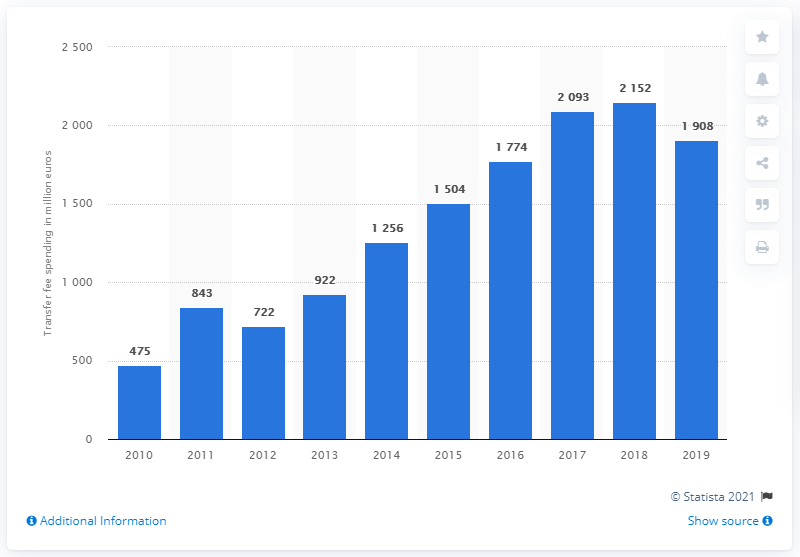Highlight a few significant elements in this photo. The transfer fees in 2019 amounted to a certain amount. 